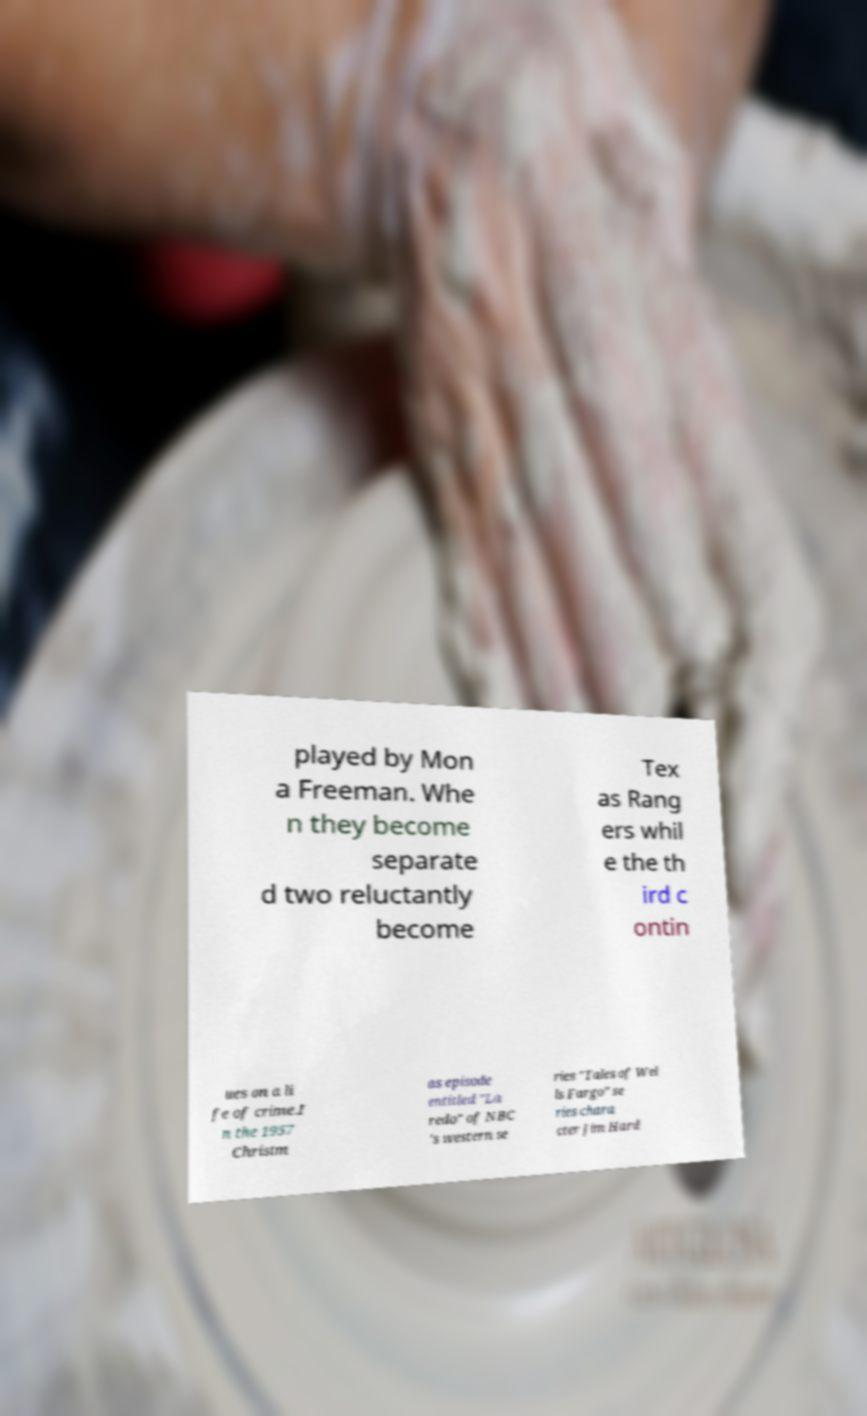For documentation purposes, I need the text within this image transcribed. Could you provide that? played by Mon a Freeman. Whe n they become separate d two reluctantly become Tex as Rang ers whil e the th ird c ontin ues on a li fe of crime.I n the 1957 Christm as episode entitled "La redo" of NBC 's western se ries "Tales of Wel ls Fargo" se ries chara cter Jim Hard 